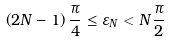<formula> <loc_0><loc_0><loc_500><loc_500>\left ( 2 N - 1 \right ) \frac { \pi } { 4 } \leq \varepsilon _ { N } < N \frac { \pi } { 2 }</formula> 